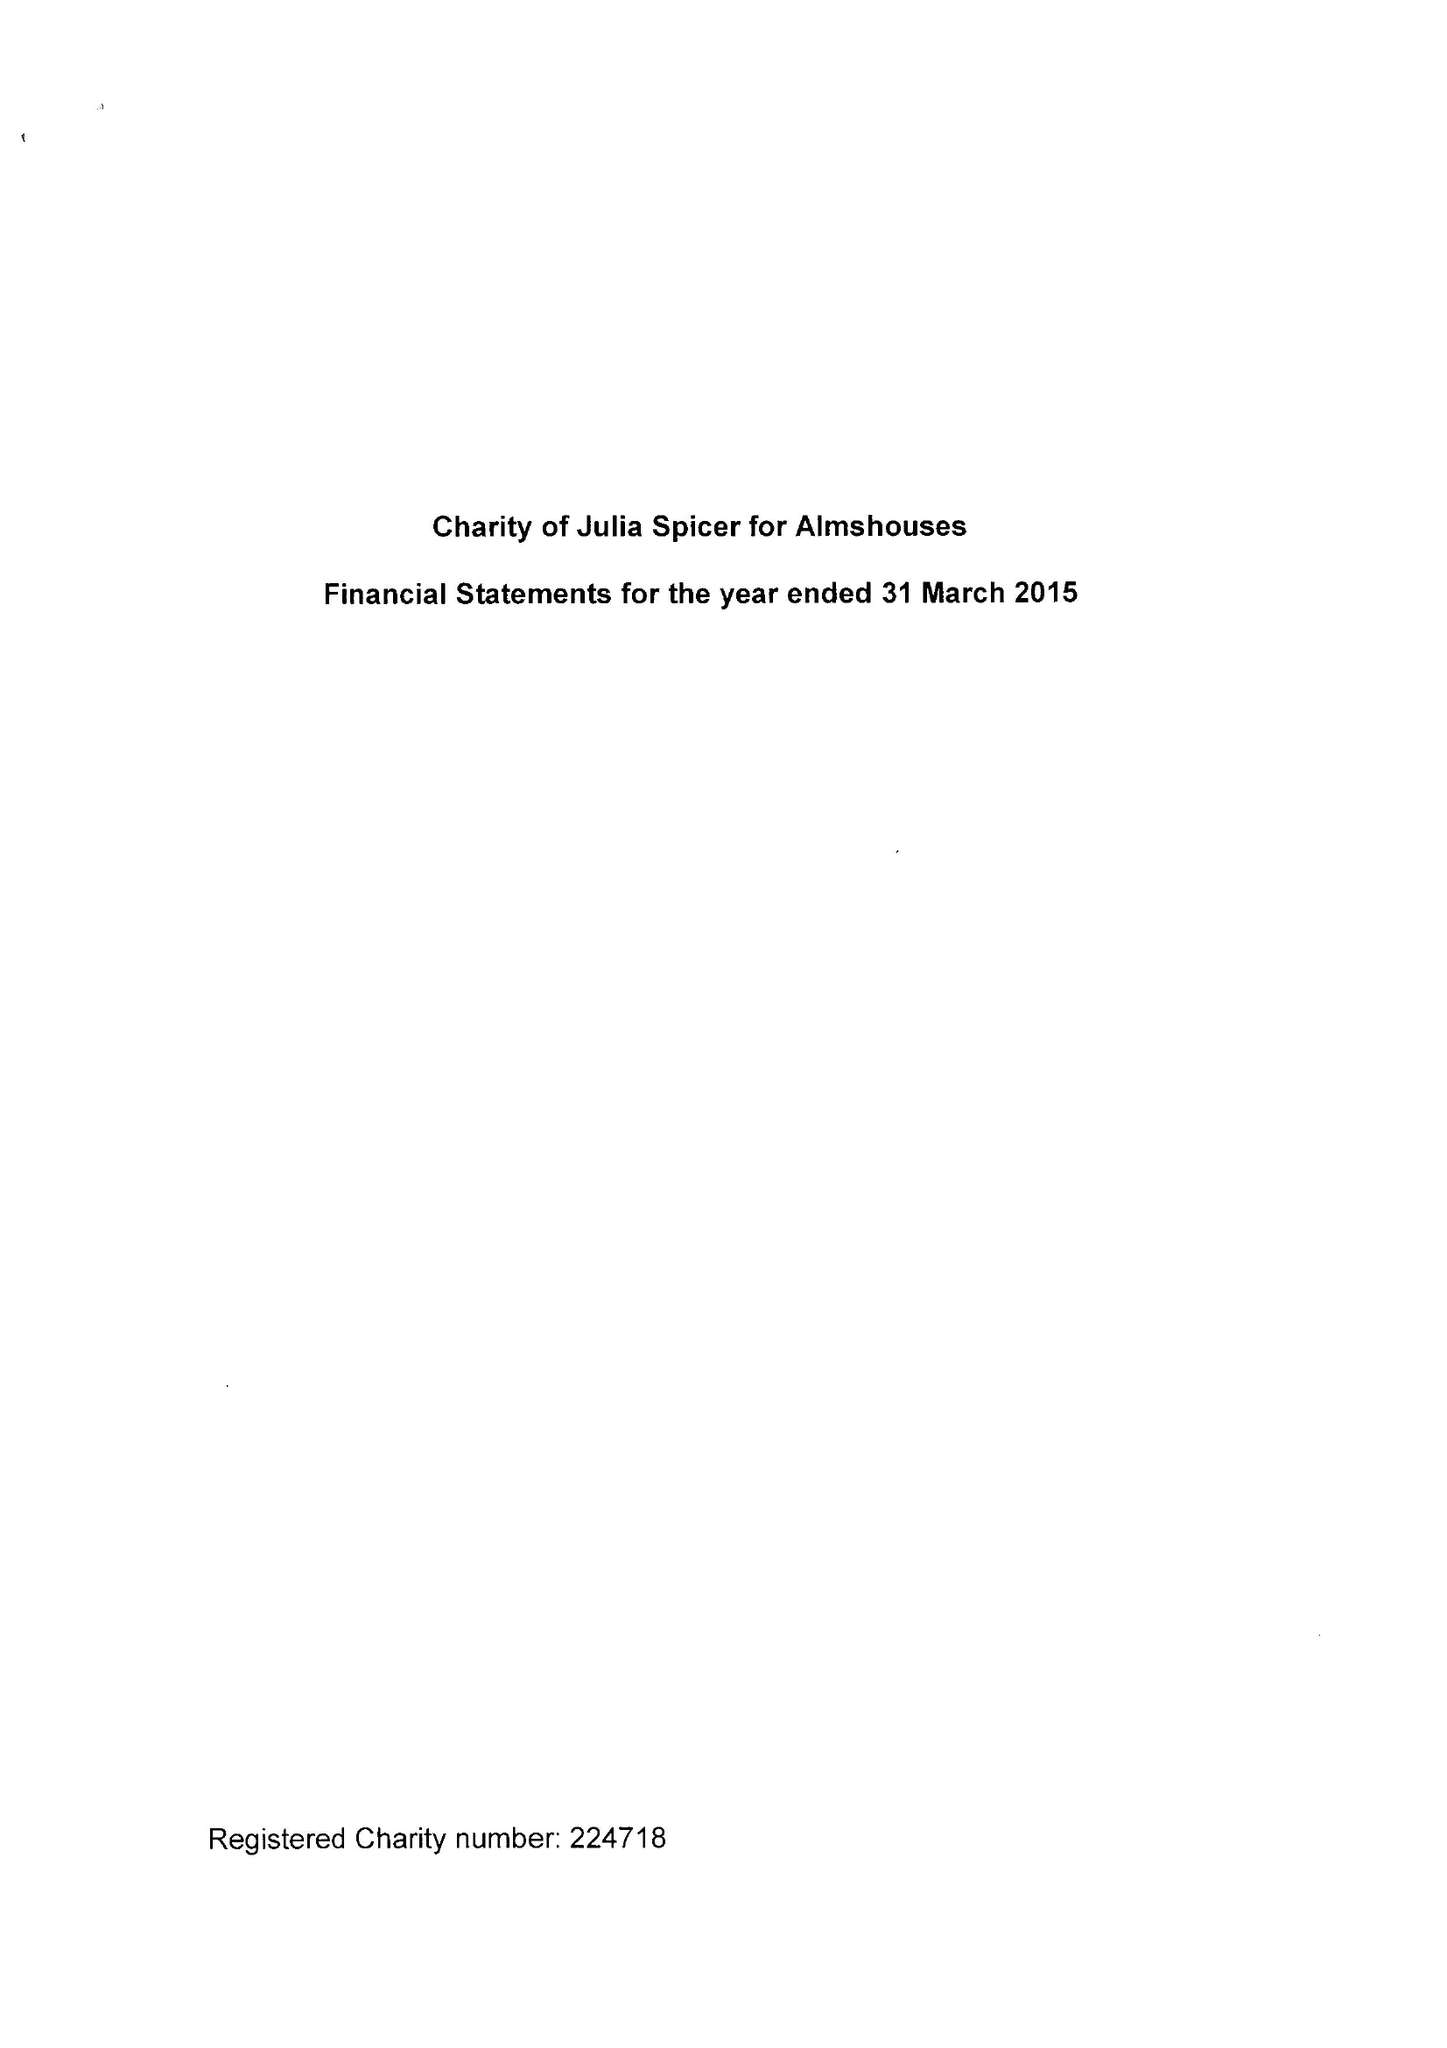What is the value for the address__postcode?
Answer the question using a single word or phrase. CR0 9XP 